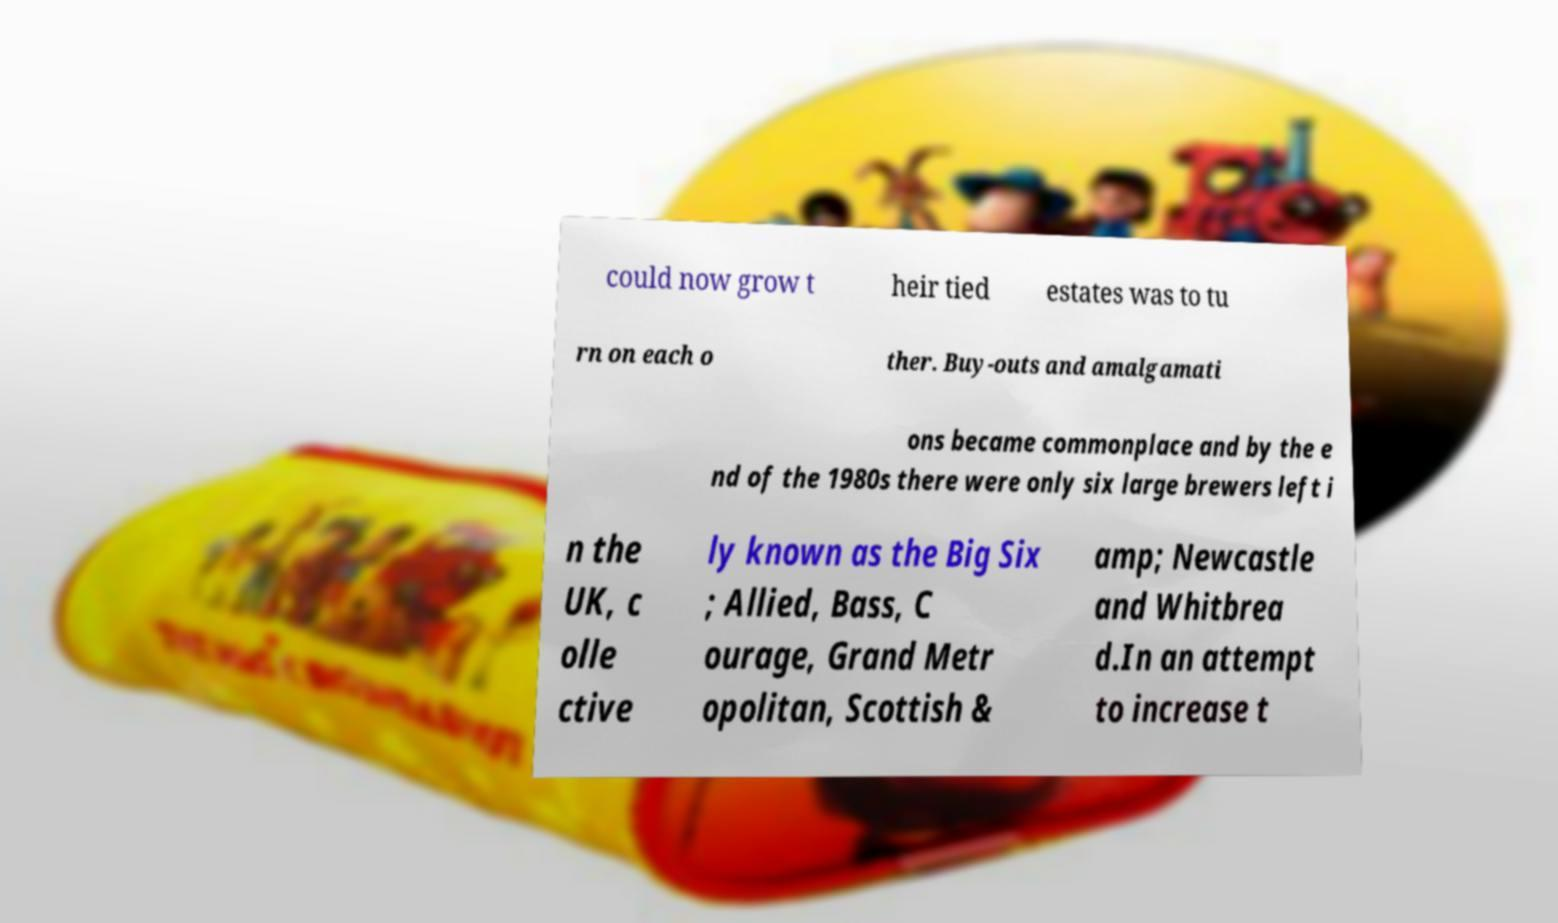Could you assist in decoding the text presented in this image and type it out clearly? could now grow t heir tied estates was to tu rn on each o ther. Buy-outs and amalgamati ons became commonplace and by the e nd of the 1980s there were only six large brewers left i n the UK, c olle ctive ly known as the Big Six ; Allied, Bass, C ourage, Grand Metr opolitan, Scottish & amp; Newcastle and Whitbrea d.In an attempt to increase t 